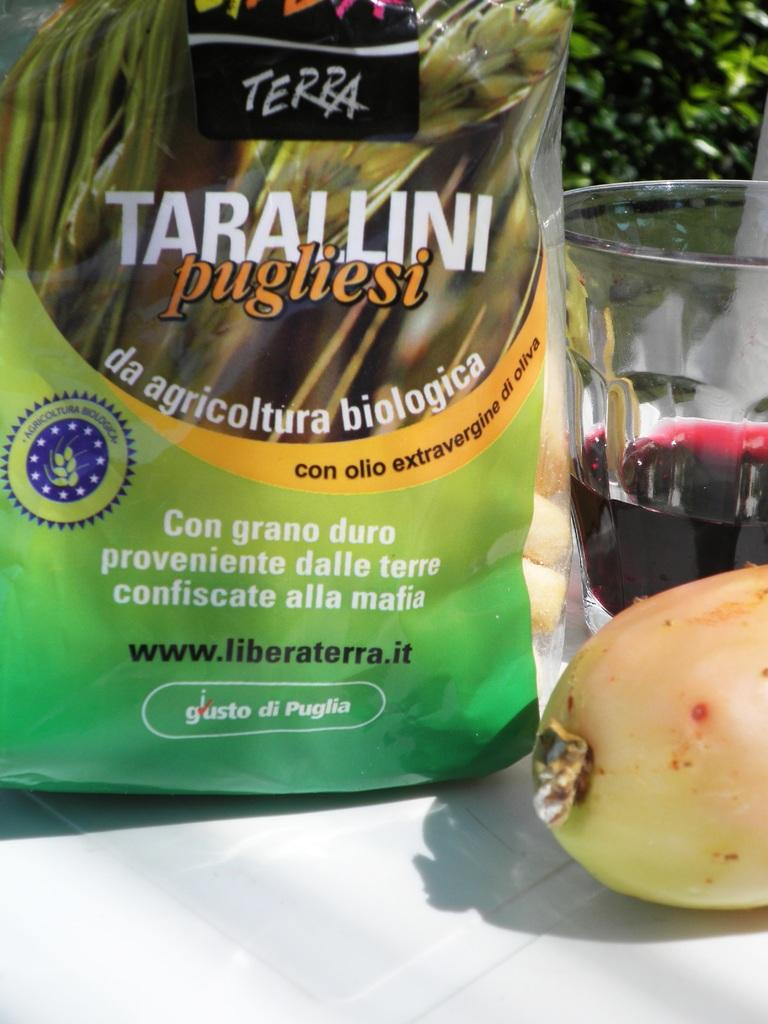Provide a one-sentence caption for the provided image. A bag of food with the name Tarallini pugliesi written on it. 